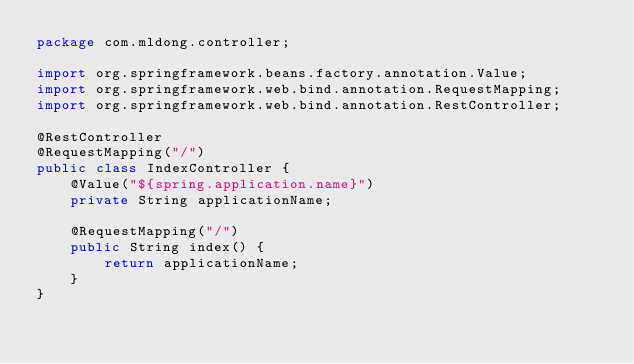Convert code to text. <code><loc_0><loc_0><loc_500><loc_500><_Java_>package com.mldong.controller;

import org.springframework.beans.factory.annotation.Value;
import org.springframework.web.bind.annotation.RequestMapping;
import org.springframework.web.bind.annotation.RestController;

@RestController
@RequestMapping("/")
public class IndexController {
    @Value("${spring.application.name}")
    private String applicationName;

    @RequestMapping("/")
    public String index() {
        return applicationName;
    }
}
</code> 